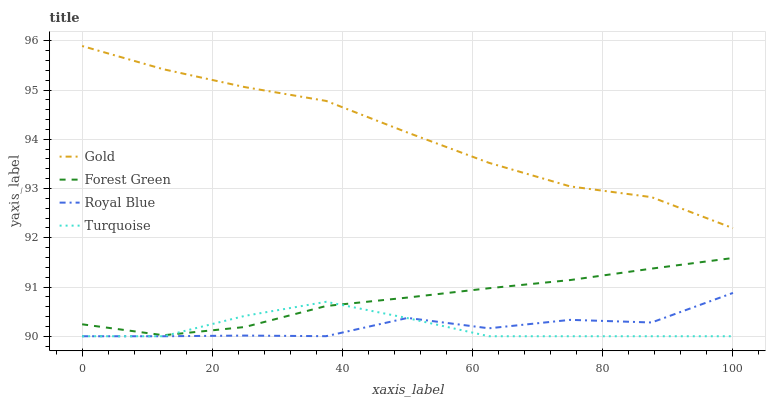Does Turquoise have the minimum area under the curve?
Answer yes or no. Yes. Does Gold have the maximum area under the curve?
Answer yes or no. Yes. Does Forest Green have the minimum area under the curve?
Answer yes or no. No. Does Forest Green have the maximum area under the curve?
Answer yes or no. No. Is Forest Green the smoothest?
Answer yes or no. Yes. Is Royal Blue the roughest?
Answer yes or no. Yes. Is Turquoise the smoothest?
Answer yes or no. No. Is Turquoise the roughest?
Answer yes or no. No. Does Royal Blue have the lowest value?
Answer yes or no. Yes. Does Forest Green have the lowest value?
Answer yes or no. No. Does Gold have the highest value?
Answer yes or no. Yes. Does Forest Green have the highest value?
Answer yes or no. No. Is Turquoise less than Gold?
Answer yes or no. Yes. Is Gold greater than Forest Green?
Answer yes or no. Yes. Does Turquoise intersect Forest Green?
Answer yes or no. Yes. Is Turquoise less than Forest Green?
Answer yes or no. No. Is Turquoise greater than Forest Green?
Answer yes or no. No. Does Turquoise intersect Gold?
Answer yes or no. No. 